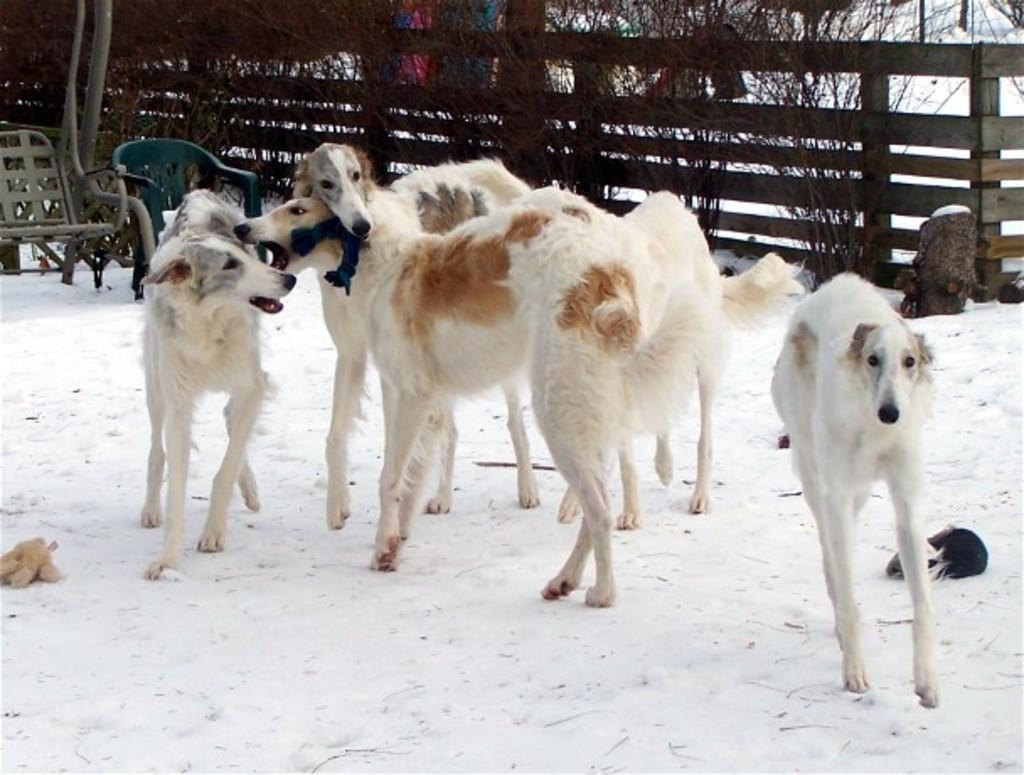Please provide a concise description of this image. In the picture we can see some dogs are standing on the snow surface and behind them, we can see two chairs and behind it, we can see a wooden railing and behind it we can see some dried plants. 